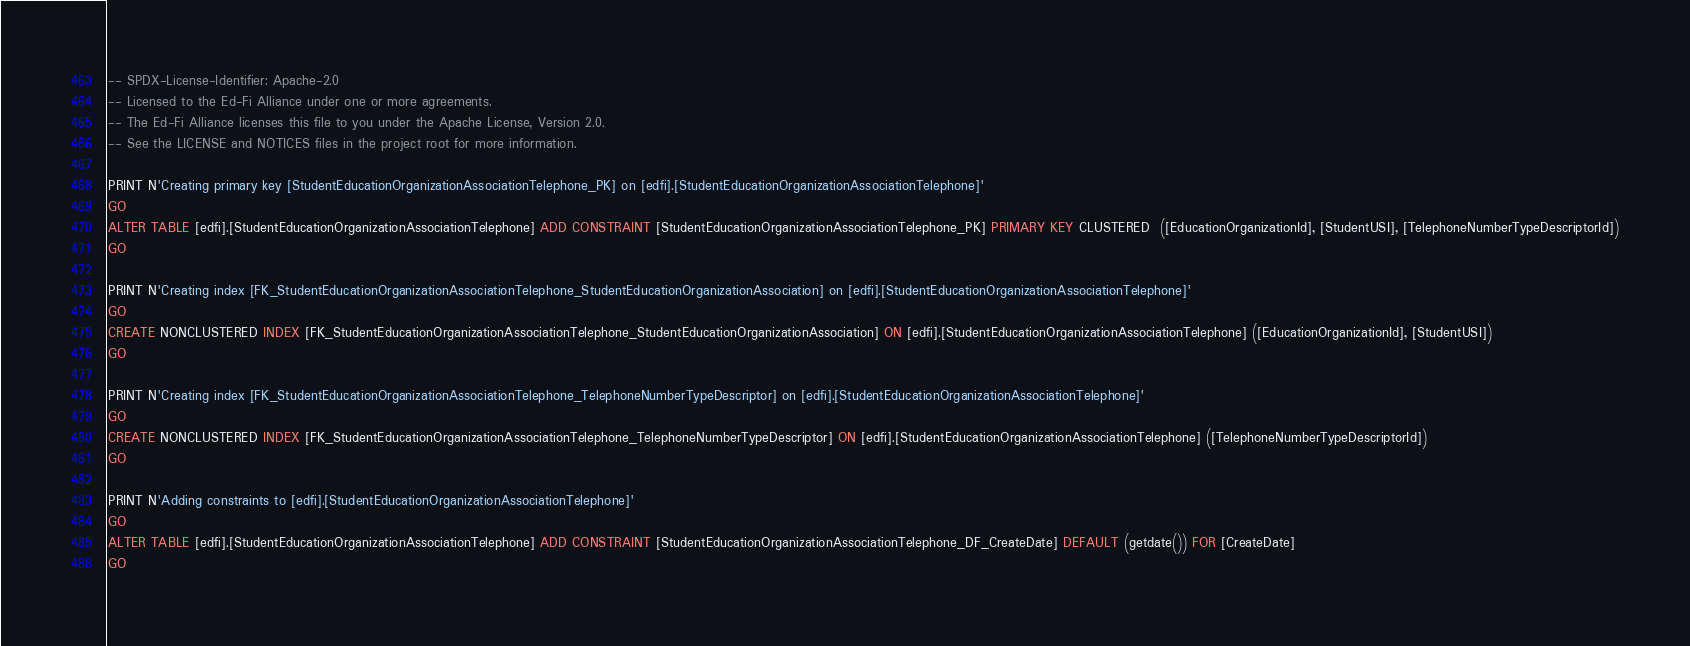<code> <loc_0><loc_0><loc_500><loc_500><_SQL_>-- SPDX-License-Identifier: Apache-2.0
-- Licensed to the Ed-Fi Alliance under one or more agreements.
-- The Ed-Fi Alliance licenses this file to you under the Apache License, Version 2.0.
-- See the LICENSE and NOTICES files in the project root for more information.

PRINT N'Creating primary key [StudentEducationOrganizationAssociationTelephone_PK] on [edfi].[StudentEducationOrganizationAssociationTelephone]'
GO
ALTER TABLE [edfi].[StudentEducationOrganizationAssociationTelephone] ADD CONSTRAINT [StudentEducationOrganizationAssociationTelephone_PK] PRIMARY KEY CLUSTERED  ([EducationOrganizationId], [StudentUSI], [TelephoneNumberTypeDescriptorId])
GO

PRINT N'Creating index [FK_StudentEducationOrganizationAssociationTelephone_StudentEducationOrganizationAssociation] on [edfi].[StudentEducationOrganizationAssociationTelephone]'
GO
CREATE NONCLUSTERED INDEX [FK_StudentEducationOrganizationAssociationTelephone_StudentEducationOrganizationAssociation] ON [edfi].[StudentEducationOrganizationAssociationTelephone] ([EducationOrganizationId], [StudentUSI])
GO

PRINT N'Creating index [FK_StudentEducationOrganizationAssociationTelephone_TelephoneNumberTypeDescriptor] on [edfi].[StudentEducationOrganizationAssociationTelephone]'
GO
CREATE NONCLUSTERED INDEX [FK_StudentEducationOrganizationAssociationTelephone_TelephoneNumberTypeDescriptor] ON [edfi].[StudentEducationOrganizationAssociationTelephone] ([TelephoneNumberTypeDescriptorId])
GO

PRINT N'Adding constraints to [edfi].[StudentEducationOrganizationAssociationTelephone]'
GO
ALTER TABLE [edfi].[StudentEducationOrganizationAssociationTelephone] ADD CONSTRAINT [StudentEducationOrganizationAssociationTelephone_DF_CreateDate] DEFAULT (getdate()) FOR [CreateDate]
GO
</code> 